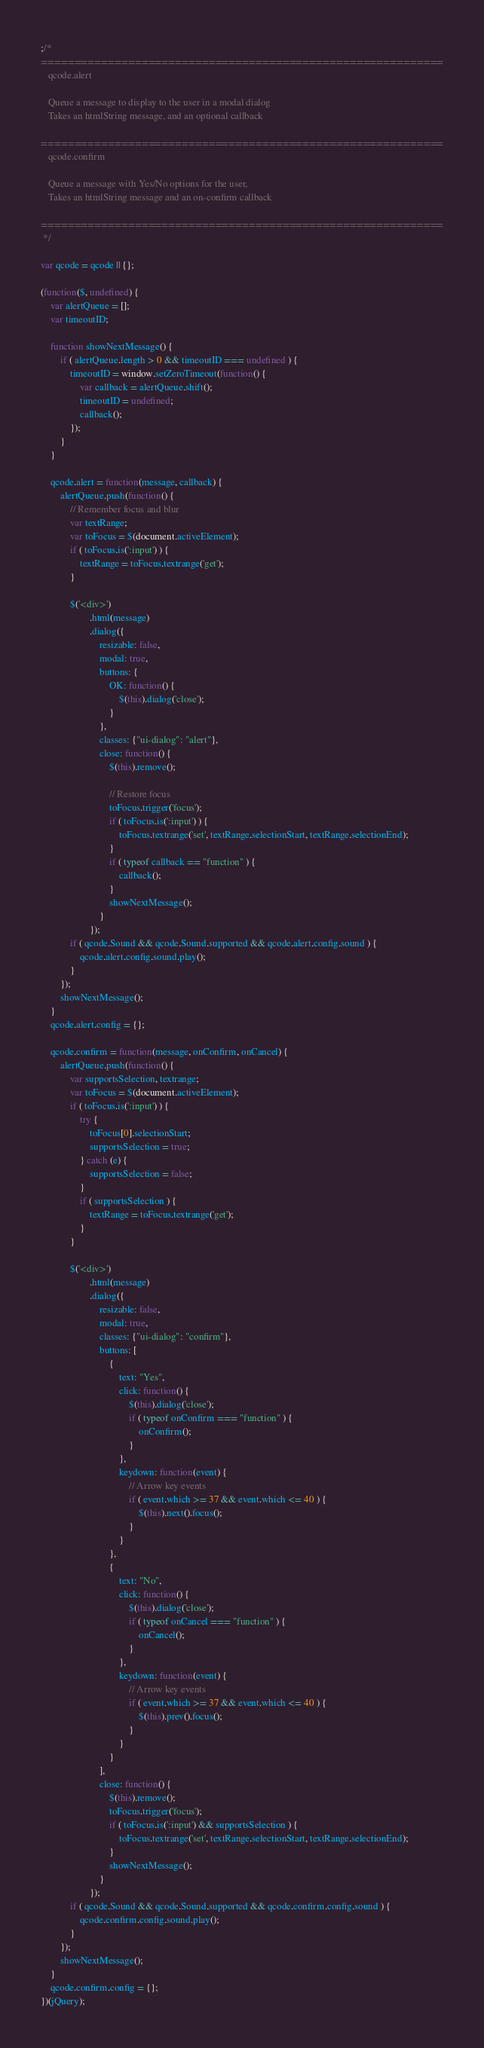Convert code to text. <code><loc_0><loc_0><loc_500><loc_500><_JavaScript_>;/*
============================================================
   qcode.alert

   Queue a message to display to the user in a modal dialog
   Takes an htmlString message, and an optional callback

============================================================
   qcode.confirm
   
   Queue a message with Yes/No options for the user,
   Takes an htmlString message and an on-confirm callback

============================================================
 */

var qcode = qcode || {};

(function($, undefined) {
    var alertQueue = [];
    var timeoutID;

    function showNextMessage() {
        if ( alertQueue.length > 0 && timeoutID === undefined ) {
            timeoutID = window.setZeroTimeout(function() {
                var callback = alertQueue.shift();
                timeoutID = undefined;
                callback();
            });
        }
    }

    qcode.alert = function(message, callback) {
        alertQueue.push(function() {
            // Remember focus and blur
            var textRange;
            var toFocus = $(document.activeElement);
            if ( toFocus.is(':input') ) {
                textRange = toFocus.textrange('get');
            }
            
            $('<div>')
                    .html(message)
                    .dialog({
                        resizable: false,
                        modal: true,
                        buttons: {
                            OK: function() {
                                $(this).dialog('close');
                            }
                        },
                        classes: {"ui-dialog": "alert"},
                        close: function() {
                            $(this).remove();
                            
                            // Restore focus
                            toFocus.trigger('focus');
                            if ( toFocus.is(':input') ) {
                                toFocus.textrange('set', textRange.selectionStart, textRange.selectionEnd);
                            }
                            if ( typeof callback == "function" ) {
                                callback();
                            }
                            showNextMessage();
                        }
                    });
            if ( qcode.Sound && qcode.Sound.supported && qcode.alert.config.sound ) {
                qcode.alert.config.sound.play();
            }
        });
        showNextMessage();
    }
    qcode.alert.config = {};

    qcode.confirm = function(message, onConfirm, onCancel) {
        alertQueue.push(function() {
            var supportsSelection, textrange;
            var toFocus = $(document.activeElement);
            if ( toFocus.is(':input') ) {
                try {
                    toFocus[0].selectionStart;
                    supportsSelection = true;
                } catch (e) {
                    supportsSelection = false;
                }
                if ( supportsSelection ) {
                    textRange = toFocus.textrange('get');
                }
            }
            
            $('<div>')
                    .html(message)
                    .dialog({
                        resizable: false,
                        modal: true,
                        classes: {"ui-dialog": "confirm"},
                        buttons: [
                            {
                                text: "Yes",
                                click: function() {
                                    $(this).dialog('close');
                                    if ( typeof onConfirm === "function" ) {
                                        onConfirm();
                                    }
                                },
                                keydown: function(event) {
                                    // Arrow key events
                                    if ( event.which >= 37 && event.which <= 40 ) {
                                        $(this).next().focus();
                                    }
                                }
                            },
                            {
                                text: "No",
                                click: function() {
                                    $(this).dialog('close');
                                    if ( typeof onCancel === "function" ) {
                                        onCancel();
                                    }
                                },
                                keydown: function(event) {
                                    // Arrow key events
                                    if ( event.which >= 37 && event.which <= 40 ) {
                                        $(this).prev().focus();
                                    }
                                }
                            }
                        ],
                        close: function() {
                            $(this).remove();
                            toFocus.trigger('focus');
                            if ( toFocus.is(':input') && supportsSelection ) {
                                toFocus.textrange('set', textRange.selectionStart, textRange.selectionEnd);
                            }
                            showNextMessage();
                        }
                    });
            if ( qcode.Sound && qcode.Sound.supported && qcode.confirm.config.sound ) {
                qcode.confirm.config.sound.play();
            }
        });
        showNextMessage();
    }
    qcode.confirm.config = {};
})(jQuery);
</code> 